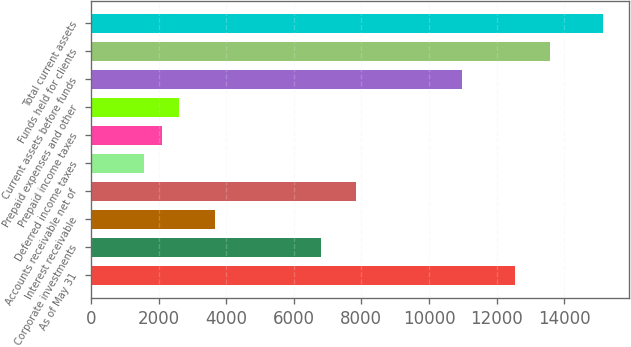Convert chart to OTSL. <chart><loc_0><loc_0><loc_500><loc_500><bar_chart><fcel>As of May 31<fcel>Corporate investments<fcel>Interest receivable<fcel>Accounts receivable net of<fcel>Deferred income taxes<fcel>Prepaid income taxes<fcel>Prepaid expenses and other<fcel>Current assets before funds<fcel>Funds held for clients<fcel>Total current assets<nl><fcel>12538.2<fcel>6793.14<fcel>3659.46<fcel>7837.7<fcel>1570.34<fcel>2092.62<fcel>2614.9<fcel>10971.4<fcel>13582.8<fcel>15149.6<nl></chart> 